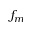Convert formula to latex. <formula><loc_0><loc_0><loc_500><loc_500>f _ { m }</formula> 